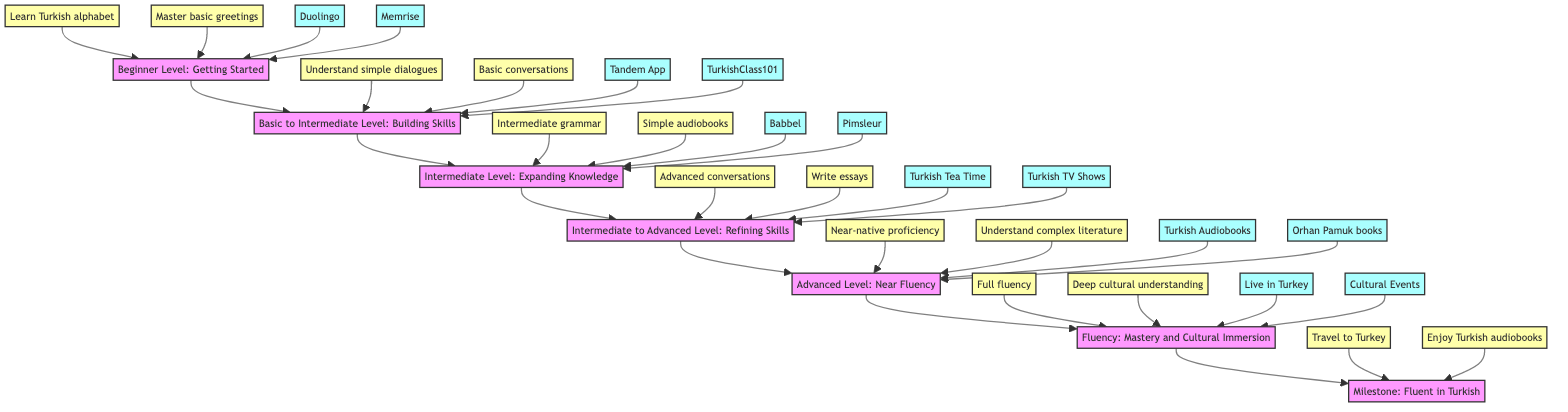What is the title of the first level? The first node in the flow chart is labeled "Beginner Level: Getting Started," indicating the starting point of the journey to learn Turkish.
Answer: Beginner Level: Getting Started How many resources are listed under the "Intermediate Level"? The "Intermediate Level" node has two resources listed: Babbel and Pimsleur. Therefore, the number of resources for this level is counted as two.
Answer: 2 What is the milestone of the "Advanced Level"? The milestone for the "Advanced Level" is twofold: to achieve near-native listening and speaking proficiency, and to read and understand complex literature. This indicates the expected achievements at this stage.
Answer: Near-native proficiency, complex literature Which resource is suggested for the "Basic to Intermediate Level"? The flow chart lists two resources under the "Basic to Intermediate Level," one of which is the Tandem App. It is a specific suggestion aimed at helping learners progress at this level.
Answer: Tandem App Which level comes after "Intermediate Level"? The diagram indicates a direct progression from the "Intermediate Level" to the "Intermediate to Advanced Level," showing the structured nature of learning Turkish.
Answer: Intermediate to Advanced Level What are the milestones for the "Fluency: Mastery and Cultural Immersion" stage? This stage includes achieving full fluency in all aspects of the language and deepening cultural understanding and appreciation. These represent critical accomplishments at this fluency stage.
Answer: Full fluency, deep cultural understanding What level follows the "Advanced Level"? According to the flow chart, the next stage after "Advanced Level" is "Fluency: Mastery and Cultural Immersion," indicating a clear progression towards expertise in the language.
Answer: Fluency: Mastery and Cultural Immersion How are the resources and milestones represented in the diagram? The diagram categorizes resources and milestones into two distinct presentations: resources are denoted as specific tools or platforms, while milestones represent key achievements and skills to be attained at each learning level.
Answer: Resources and milestones are differentiated 